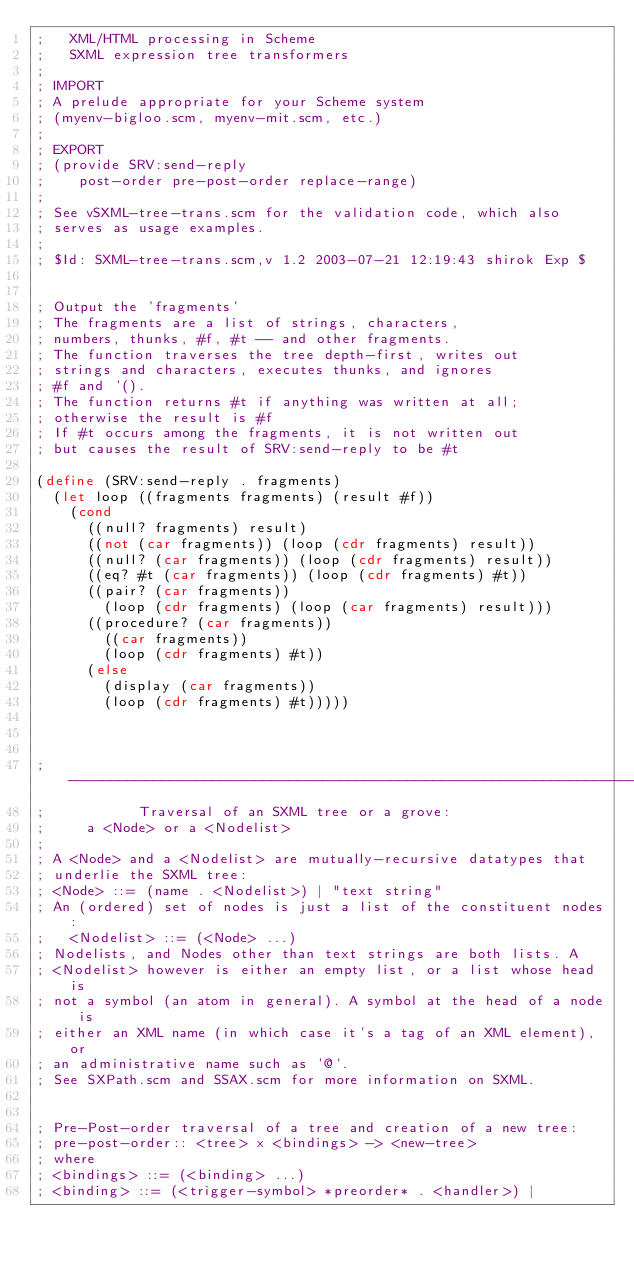Convert code to text. <code><loc_0><loc_0><loc_500><loc_500><_Scheme_>;		XML/HTML processing in Scheme
;		SXML expression tree transformers
;
; IMPORT
; A prelude appropriate for your Scheme system
;	(myenv-bigloo.scm, myenv-mit.scm, etc.)
;
; EXPORT
; (provide SRV:send-reply
;	   post-order pre-post-order replace-range)
;
; See vSXML-tree-trans.scm for the validation code, which also
; serves as usage examples.
;
; $Id: SXML-tree-trans.scm,v 1.2 2003-07-21 12:19:43 shirok Exp $


; Output the 'fragments'
; The fragments are a list of strings, characters,
; numbers, thunks, #f, #t -- and other fragments.
; The function traverses the tree depth-first, writes out
; strings and characters, executes thunks, and ignores
; #f and '().
; The function returns #t if anything was written at all;
; otherwise the result is #f
; If #t occurs among the fragments, it is not written out
; but causes the result of SRV:send-reply to be #t

(define (SRV:send-reply . fragments)
  (let loop ((fragments fragments) (result #f))
    (cond
      ((null? fragments) result)
      ((not (car fragments)) (loop (cdr fragments) result))
      ((null? (car fragments)) (loop (cdr fragments) result))
      ((eq? #t (car fragments)) (loop (cdr fragments) #t))
      ((pair? (car fragments))
        (loop (cdr fragments) (loop (car fragments) result)))
      ((procedure? (car fragments))
        ((car fragments))
        (loop (cdr fragments) #t))
      (else
        (display (car fragments))
        (loop (cdr fragments) #t)))))



;------------------------------------------------------------------------
;	          Traversal of an SXML tree or a grove:
;			a <Node> or a <Nodelist>
;
; A <Node> and a <Nodelist> are mutually-recursive datatypes that
; underlie the SXML tree:
;	<Node> ::= (name . <Nodelist>) | "text string"
; An (ordered) set of nodes is just a list of the constituent nodes:
; 	<Nodelist> ::= (<Node> ...)
; Nodelists, and Nodes other than text strings are both lists. A
; <Nodelist> however is either an empty list, or a list whose head is
; not a symbol (an atom in general). A symbol at the head of a node is
; either an XML name (in which case it's a tag of an XML element), or
; an administrative name such as '@'.
; See SXPath.scm and SSAX.scm for more information on SXML.


; Pre-Post-order traversal of a tree and creation of a new tree:
;	pre-post-order:: <tree> x <bindings> -> <new-tree>
; where
; <bindings> ::= (<binding> ...)
; <binding> ::= (<trigger-symbol> *preorder* . <handler>) |</code> 